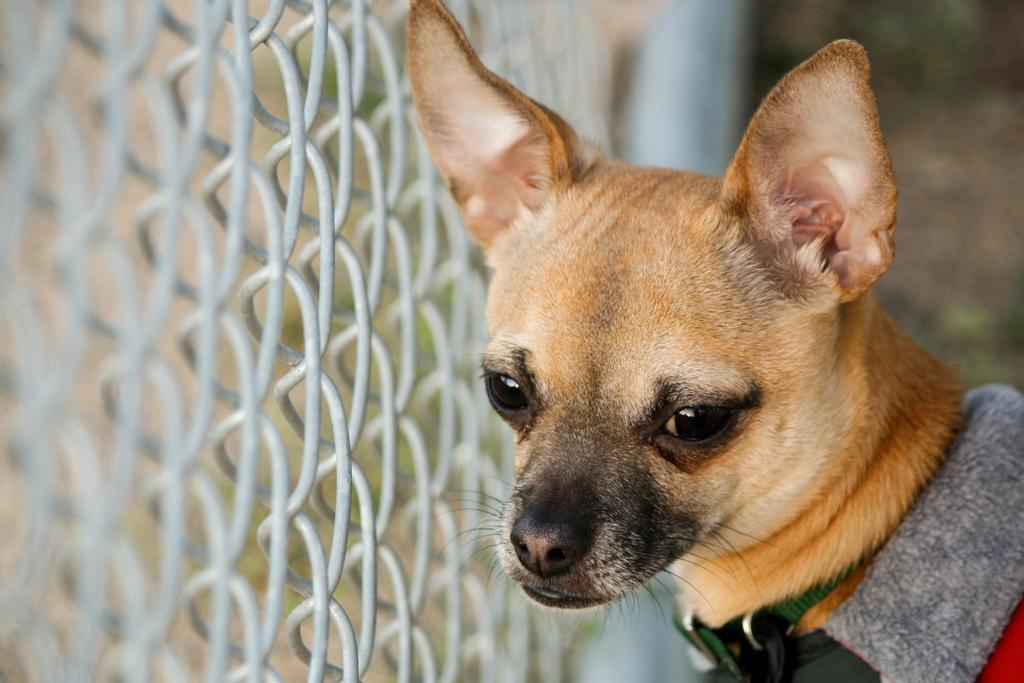What type of animal is in the image? There is a dog in the image. What can be seen on the left side of the image? There is fencing on the left side of the image. What type of plate is being used to create friction on the dog's fur in the image? There is no plate or friction present in the image; it features a dog and fencing. 